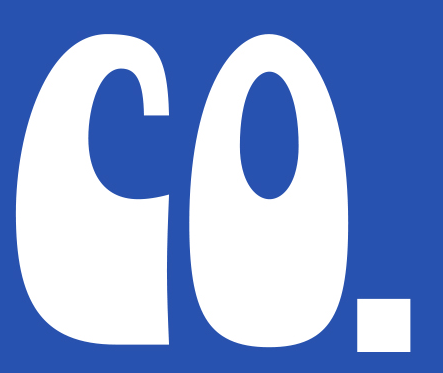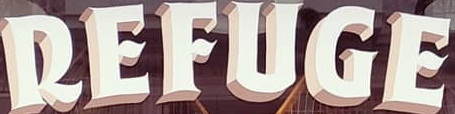Read the text content from these images in order, separated by a semicolon. CO.; REFUGE 